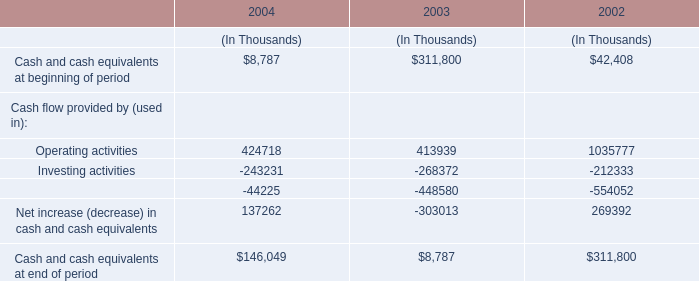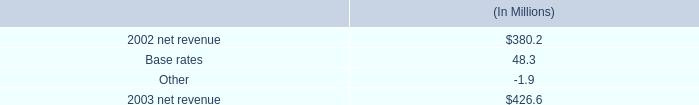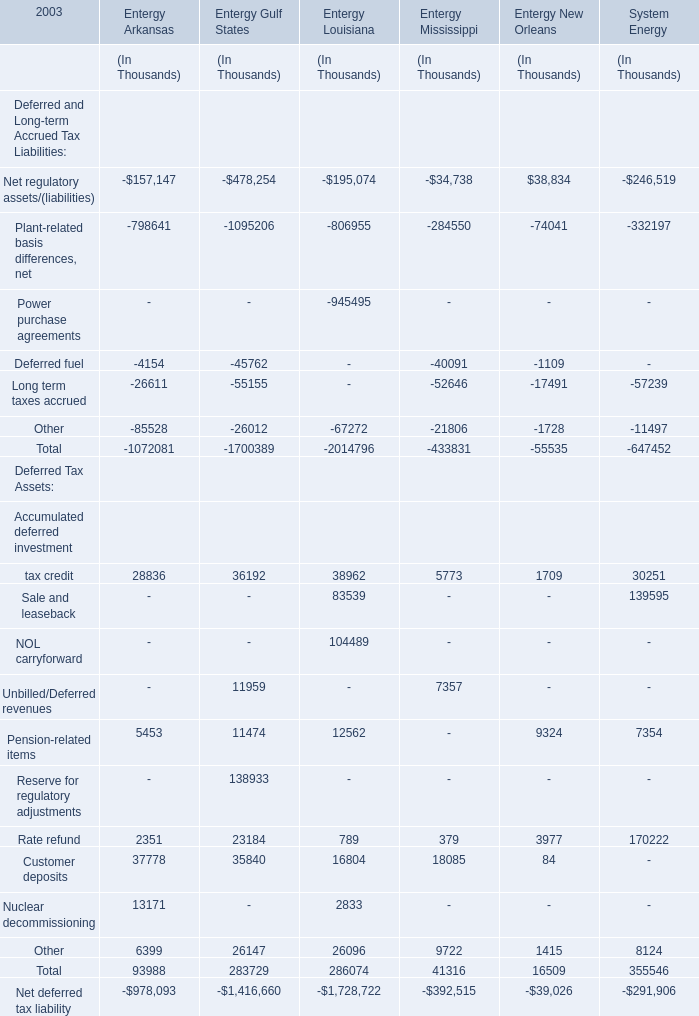what is the decrease in gross wholesale revenue as a percentage of 2003 net revenue? 
Computations: (35.9 / 426.6)
Answer: 0.08415. 